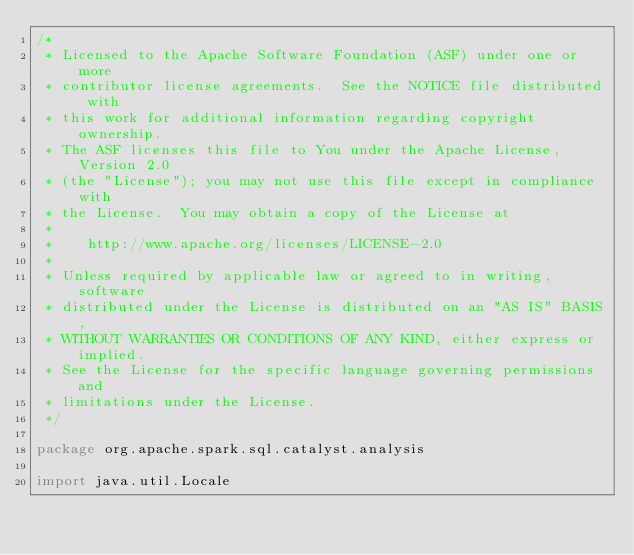<code> <loc_0><loc_0><loc_500><loc_500><_Scala_>/*
 * Licensed to the Apache Software Foundation (ASF) under one or more
 * contributor license agreements.  See the NOTICE file distributed with
 * this work for additional information regarding copyright ownership.
 * The ASF licenses this file to You under the Apache License, Version 2.0
 * (the "License"); you may not use this file except in compliance with
 * the License.  You may obtain a copy of the License at
 *
 *    http://www.apache.org/licenses/LICENSE-2.0
 *
 * Unless required by applicable law or agreed to in writing, software
 * distributed under the License is distributed on an "AS IS" BASIS,
 * WITHOUT WARRANTIES OR CONDITIONS OF ANY KIND, either express or implied.
 * See the License for the specific language governing permissions and
 * limitations under the License.
 */

package org.apache.spark.sql.catalyst.analysis

import java.util.Locale
</code> 